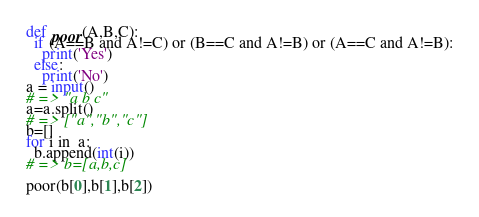<code> <loc_0><loc_0><loc_500><loc_500><_Python_>def poor(A,B,C):
  if (A==B and A!=C) or (B==C and A!=B) or (A==C and A!=B):
    print('Yes')
  else:
    print('No')
a = input()
# => "a b c"
a=a.split()
# => ["a","b","c"]
b=[]
for i in  a:
  b.append(int(i))
# => b=[a,b,c]

poor(b[0],b[1],b[2])</code> 